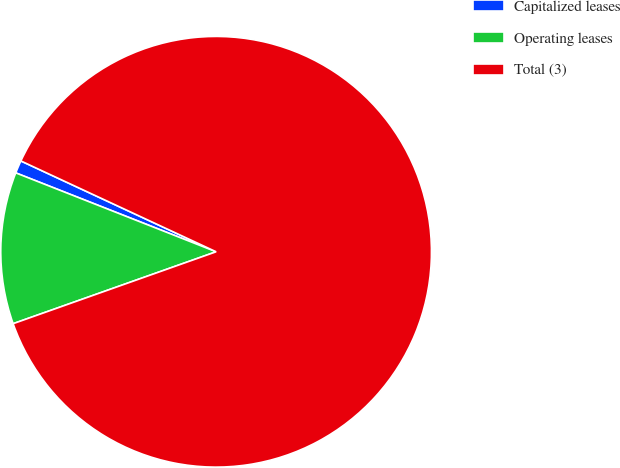Convert chart. <chart><loc_0><loc_0><loc_500><loc_500><pie_chart><fcel>Capitalized leases<fcel>Operating leases<fcel>Total (3)<nl><fcel>0.96%<fcel>11.39%<fcel>87.65%<nl></chart> 